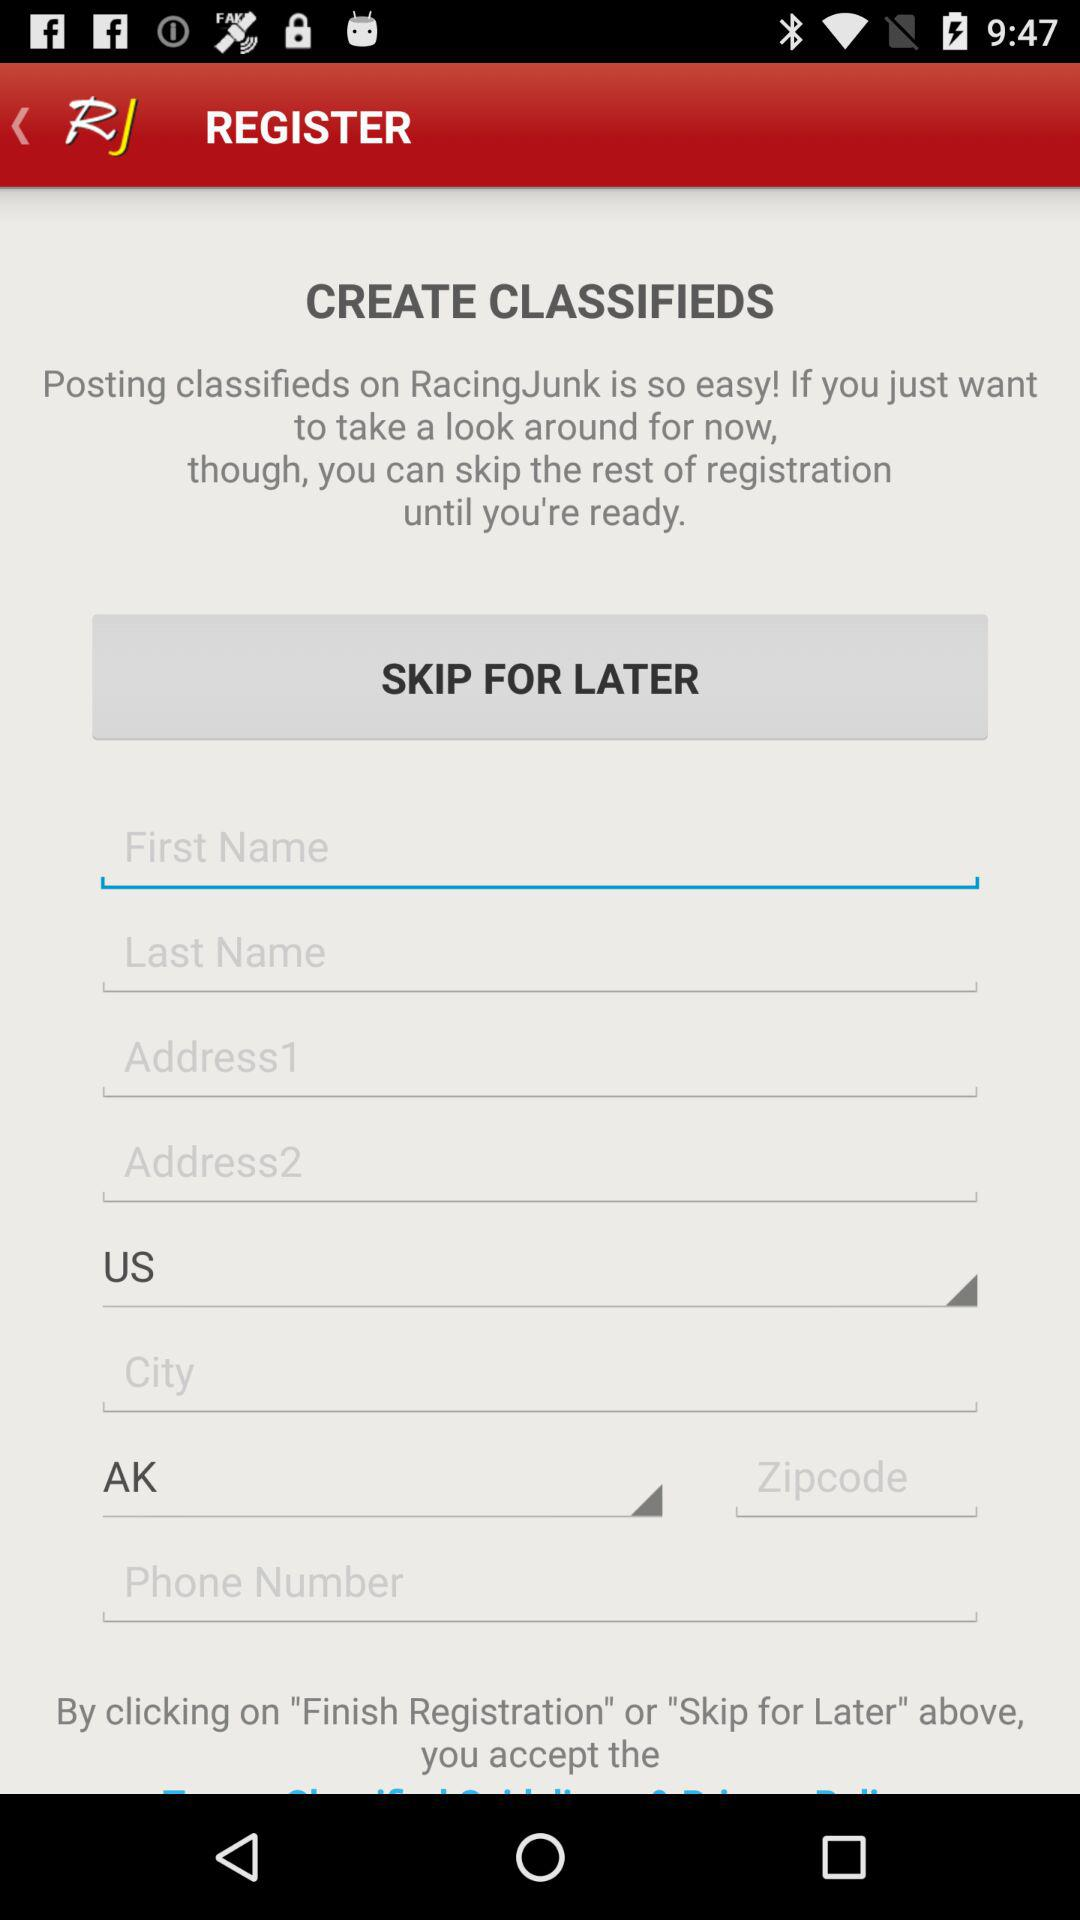What is the city?
When the provided information is insufficient, respond with <no answer>. <no answer> 